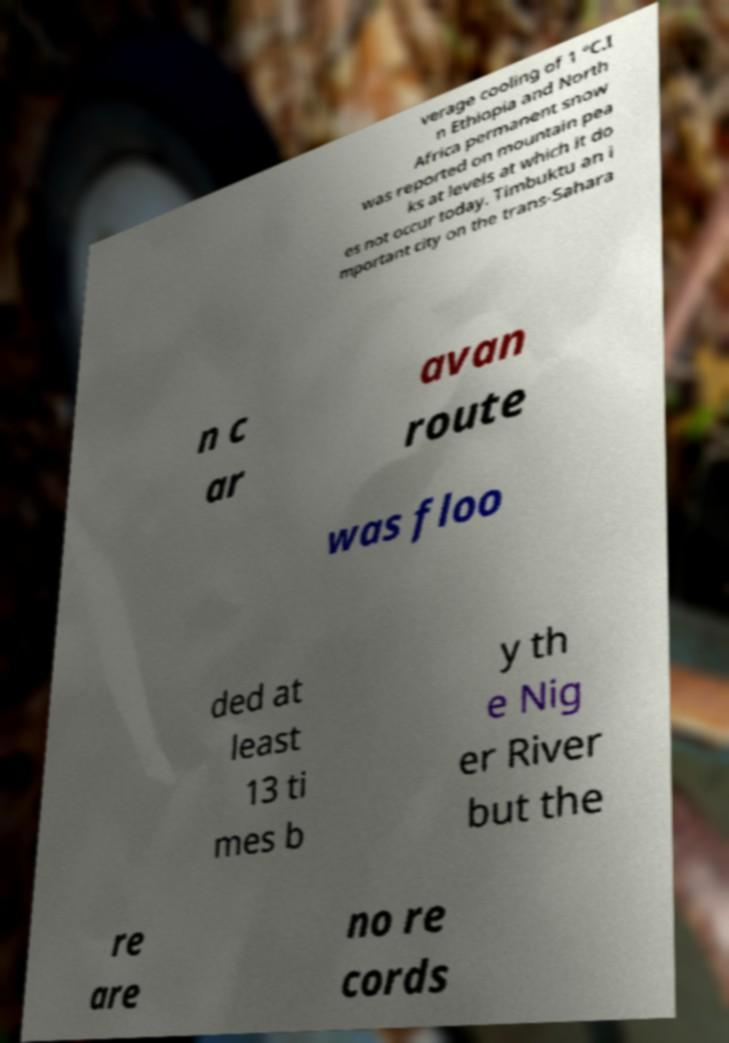Please identify and transcribe the text found in this image. verage cooling of 1 °C.I n Ethiopia and North Africa permanent snow was reported on mountain pea ks at levels at which it do es not occur today. Timbuktu an i mportant city on the trans-Sahara n c ar avan route was floo ded at least 13 ti mes b y th e Nig er River but the re are no re cords 